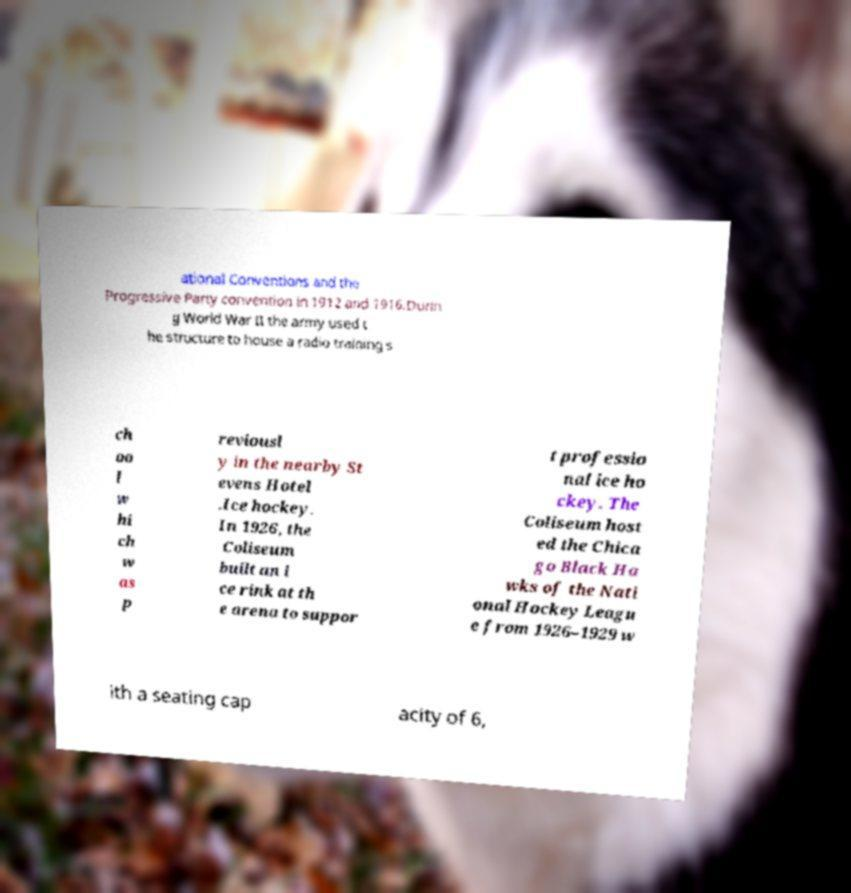I need the written content from this picture converted into text. Can you do that? ational Conventions and the Progressive Party convention in 1912 and 1916.Durin g World War II the army used t he structure to house a radio training s ch oo l w hi ch w as p reviousl y in the nearby St evens Hotel .Ice hockey. In 1926, the Coliseum built an i ce rink at th e arena to suppor t professio nal ice ho ckey. The Coliseum host ed the Chica go Black Ha wks of the Nati onal Hockey Leagu e from 1926–1929 w ith a seating cap acity of 6, 